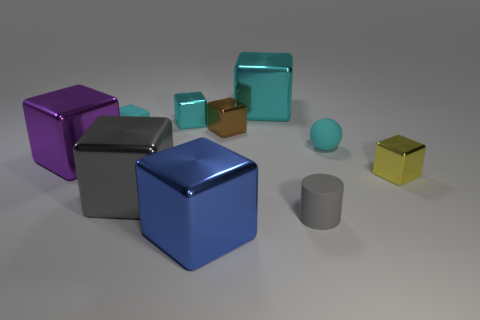Can you count all the cubes and tell me their colors? Certainly, there are six cubes in total. Starting from the left, there is a violet cube, a gray cube, a cyan cube, a teal cube, a blue cube, and finally, a yellow cube.  What objects are spherical and what colors are they? There are two spherical objects in the image. One is a cyan ball and the other is a smaller yellow ball. 